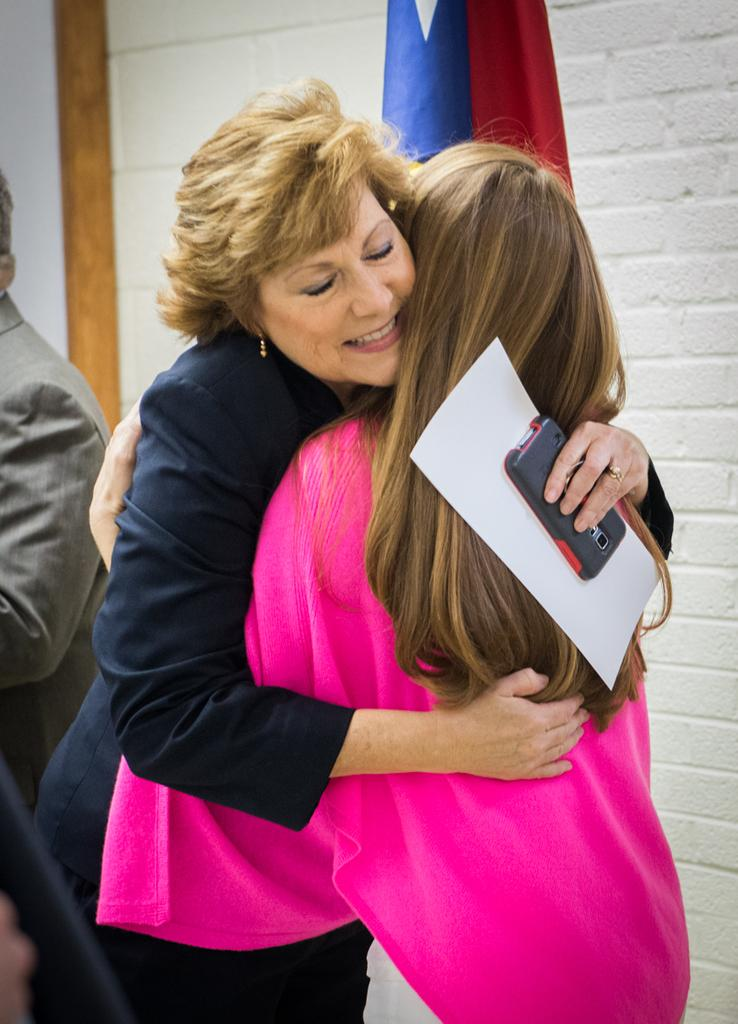How many people are in the foreground of the image? There are two women in the foreground of the image. What are the women doing in the image? The women are hugging each other. What can be seen in the background of the image? There is a man, a flag, and a wall in the background of the image. What type of tools does the carpenter have in the image? There is no carpenter present in the image, so no tools can be observed. What thought is the man in the background having in the image? There is no indication of the man's thoughts in the image, as we cannot read minds. 